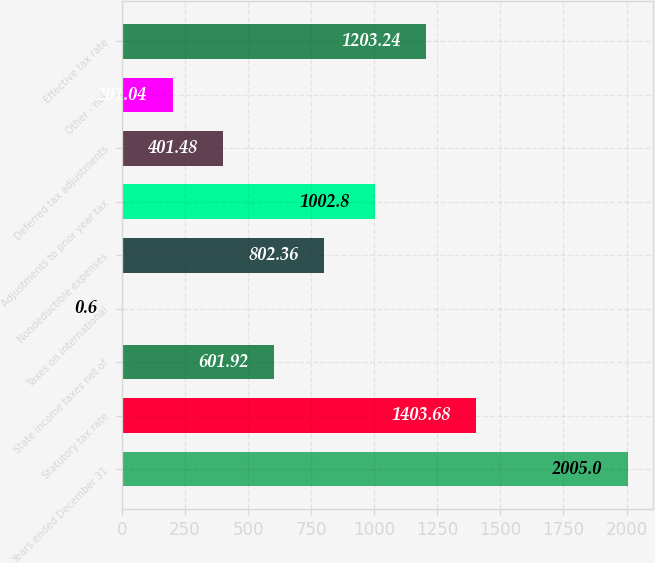Convert chart. <chart><loc_0><loc_0><loc_500><loc_500><bar_chart><fcel>Years ended December 31<fcel>Statutory tax rate<fcel>State income taxes net of<fcel>Taxes on international<fcel>Nondeductible expenses<fcel>Adjustments to prior year tax<fcel>Deferred tax adjustments<fcel>Other - net<fcel>Effective tax rate<nl><fcel>2005<fcel>1403.68<fcel>601.92<fcel>0.6<fcel>802.36<fcel>1002.8<fcel>401.48<fcel>201.04<fcel>1203.24<nl></chart> 